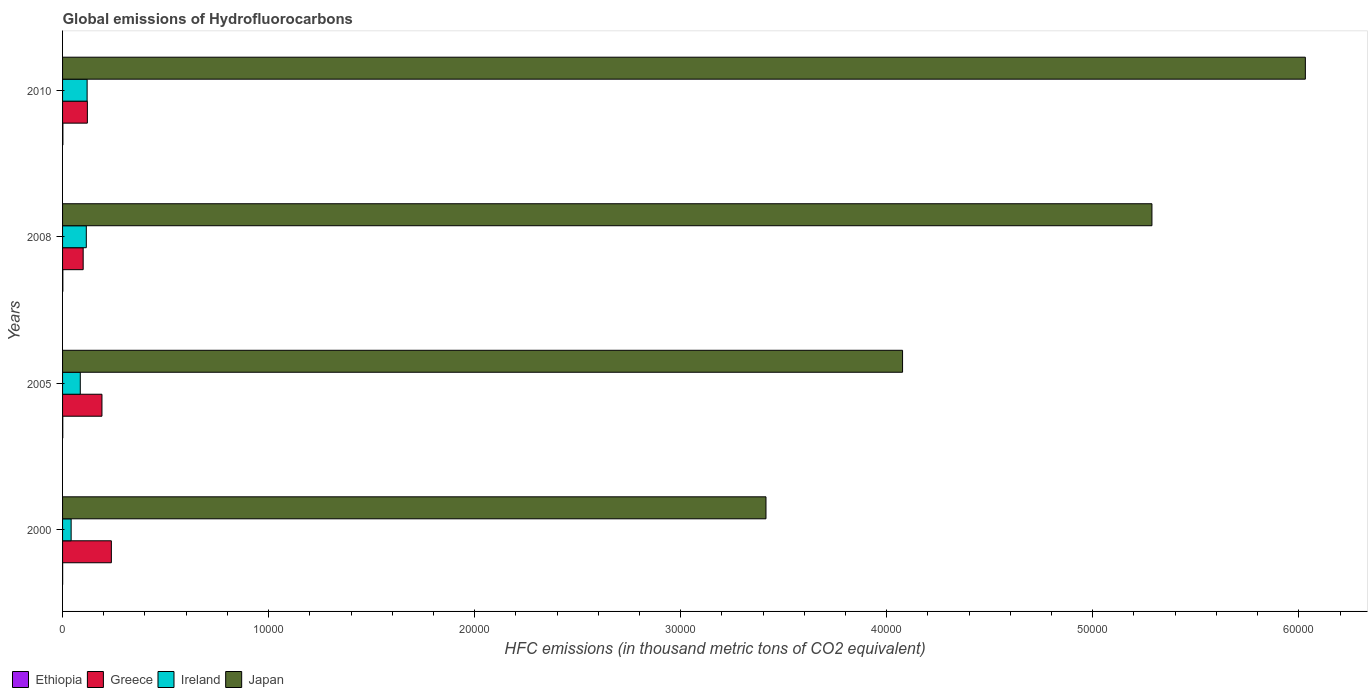Are the number of bars per tick equal to the number of legend labels?
Give a very brief answer. Yes. How many bars are there on the 4th tick from the top?
Provide a succinct answer. 4. What is the label of the 4th group of bars from the top?
Offer a very short reply. 2000. What is the global emissions of Hydrofluorocarbons in Ireland in 2008?
Make the answer very short. 1152.6. Across all years, what is the maximum global emissions of Hydrofluorocarbons in Greece?
Give a very brief answer. 2368.4. Across all years, what is the minimum global emissions of Hydrofluorocarbons in Ireland?
Give a very brief answer. 416.3. In which year was the global emissions of Hydrofluorocarbons in Japan maximum?
Your answer should be compact. 2010. In which year was the global emissions of Hydrofluorocarbons in Ireland minimum?
Provide a short and direct response. 2000. What is the total global emissions of Hydrofluorocarbons in Greece in the graph?
Offer a very short reply. 6484.1. What is the difference between the global emissions of Hydrofluorocarbons in Japan in 2000 and that in 2005?
Offer a very short reply. -6628.7. What is the difference between the global emissions of Hydrofluorocarbons in Greece in 2005 and the global emissions of Hydrofluorocarbons in Ethiopia in 2008?
Offer a very short reply. 1898.1. What is the average global emissions of Hydrofluorocarbons in Japan per year?
Your answer should be very brief. 4.70e+04. In the year 2000, what is the difference between the global emissions of Hydrofluorocarbons in Ireland and global emissions of Hydrofluorocarbons in Greece?
Offer a terse response. -1952.1. What is the ratio of the global emissions of Hydrofluorocarbons in Ireland in 2000 to that in 2010?
Provide a short and direct response. 0.35. Is the global emissions of Hydrofluorocarbons in Ethiopia in 2008 less than that in 2010?
Provide a succinct answer. Yes. What is the difference between the highest and the second highest global emissions of Hydrofluorocarbons in Greece?
Your answer should be very brief. 457. What is the difference between the highest and the lowest global emissions of Hydrofluorocarbons in Greece?
Provide a short and direct response. 1368.1. In how many years, is the global emissions of Hydrofluorocarbons in Greece greater than the average global emissions of Hydrofluorocarbons in Greece taken over all years?
Offer a terse response. 2. Is the sum of the global emissions of Hydrofluorocarbons in Ethiopia in 2000 and 2010 greater than the maximum global emissions of Hydrofluorocarbons in Japan across all years?
Offer a very short reply. No. What does the 4th bar from the top in 2005 represents?
Provide a succinct answer. Ethiopia. What does the 1st bar from the bottom in 2010 represents?
Ensure brevity in your answer.  Ethiopia. Are all the bars in the graph horizontal?
Offer a terse response. Yes. How many years are there in the graph?
Provide a succinct answer. 4. Are the values on the major ticks of X-axis written in scientific E-notation?
Provide a succinct answer. No. Does the graph contain any zero values?
Your answer should be compact. No. Where does the legend appear in the graph?
Give a very brief answer. Bottom left. What is the title of the graph?
Your response must be concise. Global emissions of Hydrofluorocarbons. What is the label or title of the X-axis?
Offer a terse response. HFC emissions (in thousand metric tons of CO2 equivalent). What is the label or title of the Y-axis?
Your response must be concise. Years. What is the HFC emissions (in thousand metric tons of CO2 equivalent) in Greece in 2000?
Make the answer very short. 2368.4. What is the HFC emissions (in thousand metric tons of CO2 equivalent) of Ireland in 2000?
Keep it short and to the point. 416.3. What is the HFC emissions (in thousand metric tons of CO2 equivalent) in Japan in 2000?
Your response must be concise. 3.41e+04. What is the HFC emissions (in thousand metric tons of CO2 equivalent) of Ethiopia in 2005?
Keep it short and to the point. 10.3. What is the HFC emissions (in thousand metric tons of CO2 equivalent) in Greece in 2005?
Your answer should be compact. 1911.4. What is the HFC emissions (in thousand metric tons of CO2 equivalent) in Ireland in 2005?
Your answer should be very brief. 859.7. What is the HFC emissions (in thousand metric tons of CO2 equivalent) in Japan in 2005?
Your answer should be compact. 4.08e+04. What is the HFC emissions (in thousand metric tons of CO2 equivalent) in Ethiopia in 2008?
Your response must be concise. 13.3. What is the HFC emissions (in thousand metric tons of CO2 equivalent) in Greece in 2008?
Your answer should be compact. 1000.3. What is the HFC emissions (in thousand metric tons of CO2 equivalent) in Ireland in 2008?
Your answer should be compact. 1152.6. What is the HFC emissions (in thousand metric tons of CO2 equivalent) in Japan in 2008?
Your answer should be compact. 5.29e+04. What is the HFC emissions (in thousand metric tons of CO2 equivalent) in Ethiopia in 2010?
Provide a short and direct response. 16. What is the HFC emissions (in thousand metric tons of CO2 equivalent) of Greece in 2010?
Provide a succinct answer. 1204. What is the HFC emissions (in thousand metric tons of CO2 equivalent) in Ireland in 2010?
Your answer should be compact. 1192. What is the HFC emissions (in thousand metric tons of CO2 equivalent) of Japan in 2010?
Offer a very short reply. 6.03e+04. Across all years, what is the maximum HFC emissions (in thousand metric tons of CO2 equivalent) of Greece?
Offer a very short reply. 2368.4. Across all years, what is the maximum HFC emissions (in thousand metric tons of CO2 equivalent) in Ireland?
Ensure brevity in your answer.  1192. Across all years, what is the maximum HFC emissions (in thousand metric tons of CO2 equivalent) of Japan?
Make the answer very short. 6.03e+04. Across all years, what is the minimum HFC emissions (in thousand metric tons of CO2 equivalent) in Ethiopia?
Offer a very short reply. 3.6. Across all years, what is the minimum HFC emissions (in thousand metric tons of CO2 equivalent) of Greece?
Keep it short and to the point. 1000.3. Across all years, what is the minimum HFC emissions (in thousand metric tons of CO2 equivalent) of Ireland?
Provide a succinct answer. 416.3. Across all years, what is the minimum HFC emissions (in thousand metric tons of CO2 equivalent) in Japan?
Your answer should be very brief. 3.41e+04. What is the total HFC emissions (in thousand metric tons of CO2 equivalent) in Ethiopia in the graph?
Make the answer very short. 43.2. What is the total HFC emissions (in thousand metric tons of CO2 equivalent) of Greece in the graph?
Offer a terse response. 6484.1. What is the total HFC emissions (in thousand metric tons of CO2 equivalent) of Ireland in the graph?
Your answer should be compact. 3620.6. What is the total HFC emissions (in thousand metric tons of CO2 equivalent) of Japan in the graph?
Your answer should be compact. 1.88e+05. What is the difference between the HFC emissions (in thousand metric tons of CO2 equivalent) of Ethiopia in 2000 and that in 2005?
Provide a succinct answer. -6.7. What is the difference between the HFC emissions (in thousand metric tons of CO2 equivalent) of Greece in 2000 and that in 2005?
Your answer should be very brief. 457. What is the difference between the HFC emissions (in thousand metric tons of CO2 equivalent) in Ireland in 2000 and that in 2005?
Your response must be concise. -443.4. What is the difference between the HFC emissions (in thousand metric tons of CO2 equivalent) in Japan in 2000 and that in 2005?
Keep it short and to the point. -6628.7. What is the difference between the HFC emissions (in thousand metric tons of CO2 equivalent) of Greece in 2000 and that in 2008?
Offer a very short reply. 1368.1. What is the difference between the HFC emissions (in thousand metric tons of CO2 equivalent) in Ireland in 2000 and that in 2008?
Provide a short and direct response. -736.3. What is the difference between the HFC emissions (in thousand metric tons of CO2 equivalent) of Japan in 2000 and that in 2008?
Your answer should be compact. -1.87e+04. What is the difference between the HFC emissions (in thousand metric tons of CO2 equivalent) of Greece in 2000 and that in 2010?
Offer a terse response. 1164.4. What is the difference between the HFC emissions (in thousand metric tons of CO2 equivalent) of Ireland in 2000 and that in 2010?
Offer a terse response. -775.7. What is the difference between the HFC emissions (in thousand metric tons of CO2 equivalent) of Japan in 2000 and that in 2010?
Make the answer very short. -2.62e+04. What is the difference between the HFC emissions (in thousand metric tons of CO2 equivalent) in Greece in 2005 and that in 2008?
Provide a succinct answer. 911.1. What is the difference between the HFC emissions (in thousand metric tons of CO2 equivalent) in Ireland in 2005 and that in 2008?
Provide a succinct answer. -292.9. What is the difference between the HFC emissions (in thousand metric tons of CO2 equivalent) of Japan in 2005 and that in 2008?
Your response must be concise. -1.21e+04. What is the difference between the HFC emissions (in thousand metric tons of CO2 equivalent) in Greece in 2005 and that in 2010?
Your answer should be very brief. 707.4. What is the difference between the HFC emissions (in thousand metric tons of CO2 equivalent) in Ireland in 2005 and that in 2010?
Give a very brief answer. -332.3. What is the difference between the HFC emissions (in thousand metric tons of CO2 equivalent) of Japan in 2005 and that in 2010?
Keep it short and to the point. -1.95e+04. What is the difference between the HFC emissions (in thousand metric tons of CO2 equivalent) in Ethiopia in 2008 and that in 2010?
Give a very brief answer. -2.7. What is the difference between the HFC emissions (in thousand metric tons of CO2 equivalent) of Greece in 2008 and that in 2010?
Your response must be concise. -203.7. What is the difference between the HFC emissions (in thousand metric tons of CO2 equivalent) of Ireland in 2008 and that in 2010?
Offer a terse response. -39.4. What is the difference between the HFC emissions (in thousand metric tons of CO2 equivalent) in Japan in 2008 and that in 2010?
Your answer should be very brief. -7446.1. What is the difference between the HFC emissions (in thousand metric tons of CO2 equivalent) of Ethiopia in 2000 and the HFC emissions (in thousand metric tons of CO2 equivalent) of Greece in 2005?
Make the answer very short. -1907.8. What is the difference between the HFC emissions (in thousand metric tons of CO2 equivalent) in Ethiopia in 2000 and the HFC emissions (in thousand metric tons of CO2 equivalent) in Ireland in 2005?
Offer a very short reply. -856.1. What is the difference between the HFC emissions (in thousand metric tons of CO2 equivalent) in Ethiopia in 2000 and the HFC emissions (in thousand metric tons of CO2 equivalent) in Japan in 2005?
Ensure brevity in your answer.  -4.08e+04. What is the difference between the HFC emissions (in thousand metric tons of CO2 equivalent) in Greece in 2000 and the HFC emissions (in thousand metric tons of CO2 equivalent) in Ireland in 2005?
Your answer should be compact. 1508.7. What is the difference between the HFC emissions (in thousand metric tons of CO2 equivalent) in Greece in 2000 and the HFC emissions (in thousand metric tons of CO2 equivalent) in Japan in 2005?
Your response must be concise. -3.84e+04. What is the difference between the HFC emissions (in thousand metric tons of CO2 equivalent) in Ireland in 2000 and the HFC emissions (in thousand metric tons of CO2 equivalent) in Japan in 2005?
Ensure brevity in your answer.  -4.04e+04. What is the difference between the HFC emissions (in thousand metric tons of CO2 equivalent) of Ethiopia in 2000 and the HFC emissions (in thousand metric tons of CO2 equivalent) of Greece in 2008?
Keep it short and to the point. -996.7. What is the difference between the HFC emissions (in thousand metric tons of CO2 equivalent) in Ethiopia in 2000 and the HFC emissions (in thousand metric tons of CO2 equivalent) in Ireland in 2008?
Your answer should be very brief. -1149. What is the difference between the HFC emissions (in thousand metric tons of CO2 equivalent) in Ethiopia in 2000 and the HFC emissions (in thousand metric tons of CO2 equivalent) in Japan in 2008?
Ensure brevity in your answer.  -5.29e+04. What is the difference between the HFC emissions (in thousand metric tons of CO2 equivalent) in Greece in 2000 and the HFC emissions (in thousand metric tons of CO2 equivalent) in Ireland in 2008?
Your response must be concise. 1215.8. What is the difference between the HFC emissions (in thousand metric tons of CO2 equivalent) of Greece in 2000 and the HFC emissions (in thousand metric tons of CO2 equivalent) of Japan in 2008?
Provide a succinct answer. -5.05e+04. What is the difference between the HFC emissions (in thousand metric tons of CO2 equivalent) in Ireland in 2000 and the HFC emissions (in thousand metric tons of CO2 equivalent) in Japan in 2008?
Your answer should be compact. -5.25e+04. What is the difference between the HFC emissions (in thousand metric tons of CO2 equivalent) in Ethiopia in 2000 and the HFC emissions (in thousand metric tons of CO2 equivalent) in Greece in 2010?
Keep it short and to the point. -1200.4. What is the difference between the HFC emissions (in thousand metric tons of CO2 equivalent) of Ethiopia in 2000 and the HFC emissions (in thousand metric tons of CO2 equivalent) of Ireland in 2010?
Provide a succinct answer. -1188.4. What is the difference between the HFC emissions (in thousand metric tons of CO2 equivalent) in Ethiopia in 2000 and the HFC emissions (in thousand metric tons of CO2 equivalent) in Japan in 2010?
Provide a short and direct response. -6.03e+04. What is the difference between the HFC emissions (in thousand metric tons of CO2 equivalent) of Greece in 2000 and the HFC emissions (in thousand metric tons of CO2 equivalent) of Ireland in 2010?
Your response must be concise. 1176.4. What is the difference between the HFC emissions (in thousand metric tons of CO2 equivalent) in Greece in 2000 and the HFC emissions (in thousand metric tons of CO2 equivalent) in Japan in 2010?
Provide a succinct answer. -5.79e+04. What is the difference between the HFC emissions (in thousand metric tons of CO2 equivalent) in Ireland in 2000 and the HFC emissions (in thousand metric tons of CO2 equivalent) in Japan in 2010?
Keep it short and to the point. -5.99e+04. What is the difference between the HFC emissions (in thousand metric tons of CO2 equivalent) of Ethiopia in 2005 and the HFC emissions (in thousand metric tons of CO2 equivalent) of Greece in 2008?
Ensure brevity in your answer.  -990. What is the difference between the HFC emissions (in thousand metric tons of CO2 equivalent) of Ethiopia in 2005 and the HFC emissions (in thousand metric tons of CO2 equivalent) of Ireland in 2008?
Make the answer very short. -1142.3. What is the difference between the HFC emissions (in thousand metric tons of CO2 equivalent) of Ethiopia in 2005 and the HFC emissions (in thousand metric tons of CO2 equivalent) of Japan in 2008?
Offer a very short reply. -5.29e+04. What is the difference between the HFC emissions (in thousand metric tons of CO2 equivalent) in Greece in 2005 and the HFC emissions (in thousand metric tons of CO2 equivalent) in Ireland in 2008?
Your answer should be very brief. 758.8. What is the difference between the HFC emissions (in thousand metric tons of CO2 equivalent) in Greece in 2005 and the HFC emissions (in thousand metric tons of CO2 equivalent) in Japan in 2008?
Provide a short and direct response. -5.10e+04. What is the difference between the HFC emissions (in thousand metric tons of CO2 equivalent) in Ireland in 2005 and the HFC emissions (in thousand metric tons of CO2 equivalent) in Japan in 2008?
Make the answer very short. -5.20e+04. What is the difference between the HFC emissions (in thousand metric tons of CO2 equivalent) of Ethiopia in 2005 and the HFC emissions (in thousand metric tons of CO2 equivalent) of Greece in 2010?
Ensure brevity in your answer.  -1193.7. What is the difference between the HFC emissions (in thousand metric tons of CO2 equivalent) in Ethiopia in 2005 and the HFC emissions (in thousand metric tons of CO2 equivalent) in Ireland in 2010?
Offer a very short reply. -1181.7. What is the difference between the HFC emissions (in thousand metric tons of CO2 equivalent) in Ethiopia in 2005 and the HFC emissions (in thousand metric tons of CO2 equivalent) in Japan in 2010?
Offer a terse response. -6.03e+04. What is the difference between the HFC emissions (in thousand metric tons of CO2 equivalent) in Greece in 2005 and the HFC emissions (in thousand metric tons of CO2 equivalent) in Ireland in 2010?
Your answer should be very brief. 719.4. What is the difference between the HFC emissions (in thousand metric tons of CO2 equivalent) of Greece in 2005 and the HFC emissions (in thousand metric tons of CO2 equivalent) of Japan in 2010?
Provide a short and direct response. -5.84e+04. What is the difference between the HFC emissions (in thousand metric tons of CO2 equivalent) in Ireland in 2005 and the HFC emissions (in thousand metric tons of CO2 equivalent) in Japan in 2010?
Offer a terse response. -5.95e+04. What is the difference between the HFC emissions (in thousand metric tons of CO2 equivalent) of Ethiopia in 2008 and the HFC emissions (in thousand metric tons of CO2 equivalent) of Greece in 2010?
Your answer should be compact. -1190.7. What is the difference between the HFC emissions (in thousand metric tons of CO2 equivalent) in Ethiopia in 2008 and the HFC emissions (in thousand metric tons of CO2 equivalent) in Ireland in 2010?
Your response must be concise. -1178.7. What is the difference between the HFC emissions (in thousand metric tons of CO2 equivalent) of Ethiopia in 2008 and the HFC emissions (in thousand metric tons of CO2 equivalent) of Japan in 2010?
Ensure brevity in your answer.  -6.03e+04. What is the difference between the HFC emissions (in thousand metric tons of CO2 equivalent) of Greece in 2008 and the HFC emissions (in thousand metric tons of CO2 equivalent) of Ireland in 2010?
Keep it short and to the point. -191.7. What is the difference between the HFC emissions (in thousand metric tons of CO2 equivalent) of Greece in 2008 and the HFC emissions (in thousand metric tons of CO2 equivalent) of Japan in 2010?
Your answer should be compact. -5.93e+04. What is the difference between the HFC emissions (in thousand metric tons of CO2 equivalent) of Ireland in 2008 and the HFC emissions (in thousand metric tons of CO2 equivalent) of Japan in 2010?
Ensure brevity in your answer.  -5.92e+04. What is the average HFC emissions (in thousand metric tons of CO2 equivalent) of Greece per year?
Make the answer very short. 1621.03. What is the average HFC emissions (in thousand metric tons of CO2 equivalent) of Ireland per year?
Your answer should be very brief. 905.15. What is the average HFC emissions (in thousand metric tons of CO2 equivalent) of Japan per year?
Your answer should be very brief. 4.70e+04. In the year 2000, what is the difference between the HFC emissions (in thousand metric tons of CO2 equivalent) of Ethiopia and HFC emissions (in thousand metric tons of CO2 equivalent) of Greece?
Keep it short and to the point. -2364.8. In the year 2000, what is the difference between the HFC emissions (in thousand metric tons of CO2 equivalent) of Ethiopia and HFC emissions (in thousand metric tons of CO2 equivalent) of Ireland?
Give a very brief answer. -412.7. In the year 2000, what is the difference between the HFC emissions (in thousand metric tons of CO2 equivalent) in Ethiopia and HFC emissions (in thousand metric tons of CO2 equivalent) in Japan?
Offer a very short reply. -3.41e+04. In the year 2000, what is the difference between the HFC emissions (in thousand metric tons of CO2 equivalent) of Greece and HFC emissions (in thousand metric tons of CO2 equivalent) of Ireland?
Offer a very short reply. 1952.1. In the year 2000, what is the difference between the HFC emissions (in thousand metric tons of CO2 equivalent) of Greece and HFC emissions (in thousand metric tons of CO2 equivalent) of Japan?
Keep it short and to the point. -3.18e+04. In the year 2000, what is the difference between the HFC emissions (in thousand metric tons of CO2 equivalent) in Ireland and HFC emissions (in thousand metric tons of CO2 equivalent) in Japan?
Your response must be concise. -3.37e+04. In the year 2005, what is the difference between the HFC emissions (in thousand metric tons of CO2 equivalent) of Ethiopia and HFC emissions (in thousand metric tons of CO2 equivalent) of Greece?
Offer a terse response. -1901.1. In the year 2005, what is the difference between the HFC emissions (in thousand metric tons of CO2 equivalent) in Ethiopia and HFC emissions (in thousand metric tons of CO2 equivalent) in Ireland?
Give a very brief answer. -849.4. In the year 2005, what is the difference between the HFC emissions (in thousand metric tons of CO2 equivalent) of Ethiopia and HFC emissions (in thousand metric tons of CO2 equivalent) of Japan?
Ensure brevity in your answer.  -4.08e+04. In the year 2005, what is the difference between the HFC emissions (in thousand metric tons of CO2 equivalent) in Greece and HFC emissions (in thousand metric tons of CO2 equivalent) in Ireland?
Ensure brevity in your answer.  1051.7. In the year 2005, what is the difference between the HFC emissions (in thousand metric tons of CO2 equivalent) of Greece and HFC emissions (in thousand metric tons of CO2 equivalent) of Japan?
Your response must be concise. -3.89e+04. In the year 2005, what is the difference between the HFC emissions (in thousand metric tons of CO2 equivalent) of Ireland and HFC emissions (in thousand metric tons of CO2 equivalent) of Japan?
Ensure brevity in your answer.  -3.99e+04. In the year 2008, what is the difference between the HFC emissions (in thousand metric tons of CO2 equivalent) in Ethiopia and HFC emissions (in thousand metric tons of CO2 equivalent) in Greece?
Keep it short and to the point. -987. In the year 2008, what is the difference between the HFC emissions (in thousand metric tons of CO2 equivalent) in Ethiopia and HFC emissions (in thousand metric tons of CO2 equivalent) in Ireland?
Give a very brief answer. -1139.3. In the year 2008, what is the difference between the HFC emissions (in thousand metric tons of CO2 equivalent) of Ethiopia and HFC emissions (in thousand metric tons of CO2 equivalent) of Japan?
Offer a very short reply. -5.29e+04. In the year 2008, what is the difference between the HFC emissions (in thousand metric tons of CO2 equivalent) in Greece and HFC emissions (in thousand metric tons of CO2 equivalent) in Ireland?
Ensure brevity in your answer.  -152.3. In the year 2008, what is the difference between the HFC emissions (in thousand metric tons of CO2 equivalent) in Greece and HFC emissions (in thousand metric tons of CO2 equivalent) in Japan?
Your answer should be very brief. -5.19e+04. In the year 2008, what is the difference between the HFC emissions (in thousand metric tons of CO2 equivalent) in Ireland and HFC emissions (in thousand metric tons of CO2 equivalent) in Japan?
Make the answer very short. -5.17e+04. In the year 2010, what is the difference between the HFC emissions (in thousand metric tons of CO2 equivalent) of Ethiopia and HFC emissions (in thousand metric tons of CO2 equivalent) of Greece?
Make the answer very short. -1188. In the year 2010, what is the difference between the HFC emissions (in thousand metric tons of CO2 equivalent) of Ethiopia and HFC emissions (in thousand metric tons of CO2 equivalent) of Ireland?
Provide a short and direct response. -1176. In the year 2010, what is the difference between the HFC emissions (in thousand metric tons of CO2 equivalent) in Ethiopia and HFC emissions (in thousand metric tons of CO2 equivalent) in Japan?
Offer a very short reply. -6.03e+04. In the year 2010, what is the difference between the HFC emissions (in thousand metric tons of CO2 equivalent) of Greece and HFC emissions (in thousand metric tons of CO2 equivalent) of Japan?
Your answer should be compact. -5.91e+04. In the year 2010, what is the difference between the HFC emissions (in thousand metric tons of CO2 equivalent) of Ireland and HFC emissions (in thousand metric tons of CO2 equivalent) of Japan?
Your answer should be very brief. -5.91e+04. What is the ratio of the HFC emissions (in thousand metric tons of CO2 equivalent) in Ethiopia in 2000 to that in 2005?
Offer a terse response. 0.35. What is the ratio of the HFC emissions (in thousand metric tons of CO2 equivalent) of Greece in 2000 to that in 2005?
Your response must be concise. 1.24. What is the ratio of the HFC emissions (in thousand metric tons of CO2 equivalent) in Ireland in 2000 to that in 2005?
Provide a short and direct response. 0.48. What is the ratio of the HFC emissions (in thousand metric tons of CO2 equivalent) in Japan in 2000 to that in 2005?
Your response must be concise. 0.84. What is the ratio of the HFC emissions (in thousand metric tons of CO2 equivalent) in Ethiopia in 2000 to that in 2008?
Provide a short and direct response. 0.27. What is the ratio of the HFC emissions (in thousand metric tons of CO2 equivalent) of Greece in 2000 to that in 2008?
Ensure brevity in your answer.  2.37. What is the ratio of the HFC emissions (in thousand metric tons of CO2 equivalent) in Ireland in 2000 to that in 2008?
Keep it short and to the point. 0.36. What is the ratio of the HFC emissions (in thousand metric tons of CO2 equivalent) in Japan in 2000 to that in 2008?
Give a very brief answer. 0.65. What is the ratio of the HFC emissions (in thousand metric tons of CO2 equivalent) in Ethiopia in 2000 to that in 2010?
Keep it short and to the point. 0.23. What is the ratio of the HFC emissions (in thousand metric tons of CO2 equivalent) in Greece in 2000 to that in 2010?
Your response must be concise. 1.97. What is the ratio of the HFC emissions (in thousand metric tons of CO2 equivalent) of Ireland in 2000 to that in 2010?
Provide a short and direct response. 0.35. What is the ratio of the HFC emissions (in thousand metric tons of CO2 equivalent) of Japan in 2000 to that in 2010?
Your answer should be compact. 0.57. What is the ratio of the HFC emissions (in thousand metric tons of CO2 equivalent) in Ethiopia in 2005 to that in 2008?
Make the answer very short. 0.77. What is the ratio of the HFC emissions (in thousand metric tons of CO2 equivalent) of Greece in 2005 to that in 2008?
Make the answer very short. 1.91. What is the ratio of the HFC emissions (in thousand metric tons of CO2 equivalent) in Ireland in 2005 to that in 2008?
Provide a succinct answer. 0.75. What is the ratio of the HFC emissions (in thousand metric tons of CO2 equivalent) in Japan in 2005 to that in 2008?
Offer a terse response. 0.77. What is the ratio of the HFC emissions (in thousand metric tons of CO2 equivalent) of Ethiopia in 2005 to that in 2010?
Keep it short and to the point. 0.64. What is the ratio of the HFC emissions (in thousand metric tons of CO2 equivalent) of Greece in 2005 to that in 2010?
Your answer should be very brief. 1.59. What is the ratio of the HFC emissions (in thousand metric tons of CO2 equivalent) of Ireland in 2005 to that in 2010?
Ensure brevity in your answer.  0.72. What is the ratio of the HFC emissions (in thousand metric tons of CO2 equivalent) of Japan in 2005 to that in 2010?
Offer a very short reply. 0.68. What is the ratio of the HFC emissions (in thousand metric tons of CO2 equivalent) of Ethiopia in 2008 to that in 2010?
Your response must be concise. 0.83. What is the ratio of the HFC emissions (in thousand metric tons of CO2 equivalent) in Greece in 2008 to that in 2010?
Give a very brief answer. 0.83. What is the ratio of the HFC emissions (in thousand metric tons of CO2 equivalent) of Ireland in 2008 to that in 2010?
Keep it short and to the point. 0.97. What is the ratio of the HFC emissions (in thousand metric tons of CO2 equivalent) of Japan in 2008 to that in 2010?
Your answer should be very brief. 0.88. What is the difference between the highest and the second highest HFC emissions (in thousand metric tons of CO2 equivalent) of Ethiopia?
Make the answer very short. 2.7. What is the difference between the highest and the second highest HFC emissions (in thousand metric tons of CO2 equivalent) of Greece?
Provide a short and direct response. 457. What is the difference between the highest and the second highest HFC emissions (in thousand metric tons of CO2 equivalent) of Ireland?
Ensure brevity in your answer.  39.4. What is the difference between the highest and the second highest HFC emissions (in thousand metric tons of CO2 equivalent) of Japan?
Make the answer very short. 7446.1. What is the difference between the highest and the lowest HFC emissions (in thousand metric tons of CO2 equivalent) of Ethiopia?
Give a very brief answer. 12.4. What is the difference between the highest and the lowest HFC emissions (in thousand metric tons of CO2 equivalent) of Greece?
Provide a short and direct response. 1368.1. What is the difference between the highest and the lowest HFC emissions (in thousand metric tons of CO2 equivalent) of Ireland?
Offer a very short reply. 775.7. What is the difference between the highest and the lowest HFC emissions (in thousand metric tons of CO2 equivalent) of Japan?
Offer a terse response. 2.62e+04. 